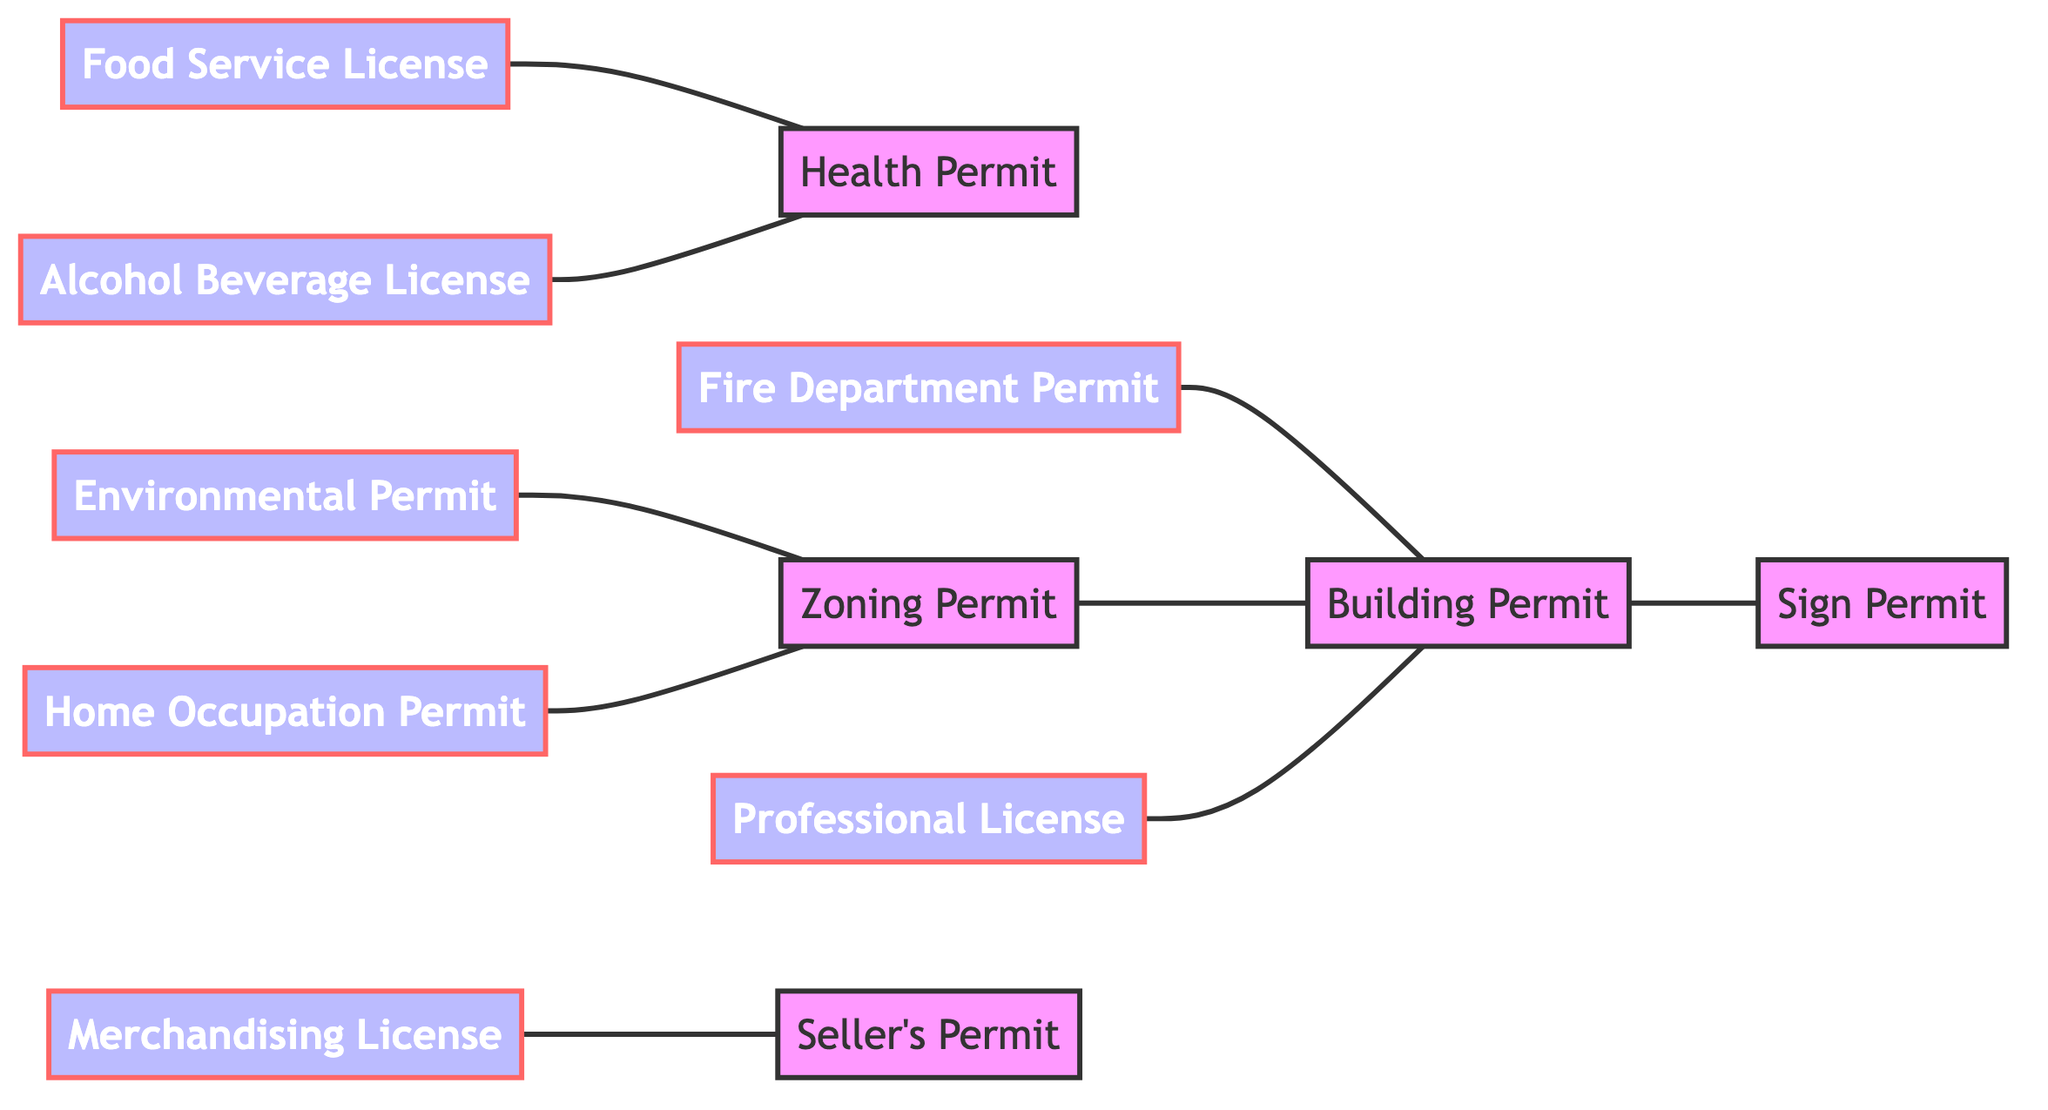What types of permits are connected to the Health Permit? The Health Permit is connected to the Food Service License and the Alcohol Beverage License, indicating that both of these permits require a Health Permit as part of their process.
Answer: Food Service License, Alcohol Beverage License How many nodes are there in the diagram? The diagram contains a total of 12 nodes, representing different types of business permits required across various sectors.
Answer: 12 What permits require a Building Permit? The Building Permit is connected to the Sign Permit, Fire Department Permit, Zoning Permit, and Professional License, indicating that all of these require a Building Permit as part of their process.
Answer: Sign Permit, Fire Department Permit, Zoning Permit, Professional License Which two permits are directly related to the Zoning Permit? The Zoning Permit is directly connected to the Building Permit and Home Occupation Permit, indicating that both of these permits require Zoning Permit approval.
Answer: Building Permit, Home Occupation Permit What is the total number of edges in the diagram? There are 8 edges in the diagram, representing the connections between the various types of business permits.
Answer: 8 Which permit is most connected to other permits? The Building Permit is connected to the largest number of other permits: Sign Permit, Fire Department Permit, Zoning Permit, and Professional License, totaling four connections.
Answer: Building Permit What type of license is directly linked to the Seller's Permit? The Merchandising License is directly linked to the Seller's Permit, indicating a requirement relationship between these two types of permits.
Answer: Merchandising License How does the Environmental Permit relate to other permits? The Environmental Permit is connected to the Zoning Permit, indicating that it relies on the Zoning Permit as part of its approval process.
Answer: Zoning Permit 